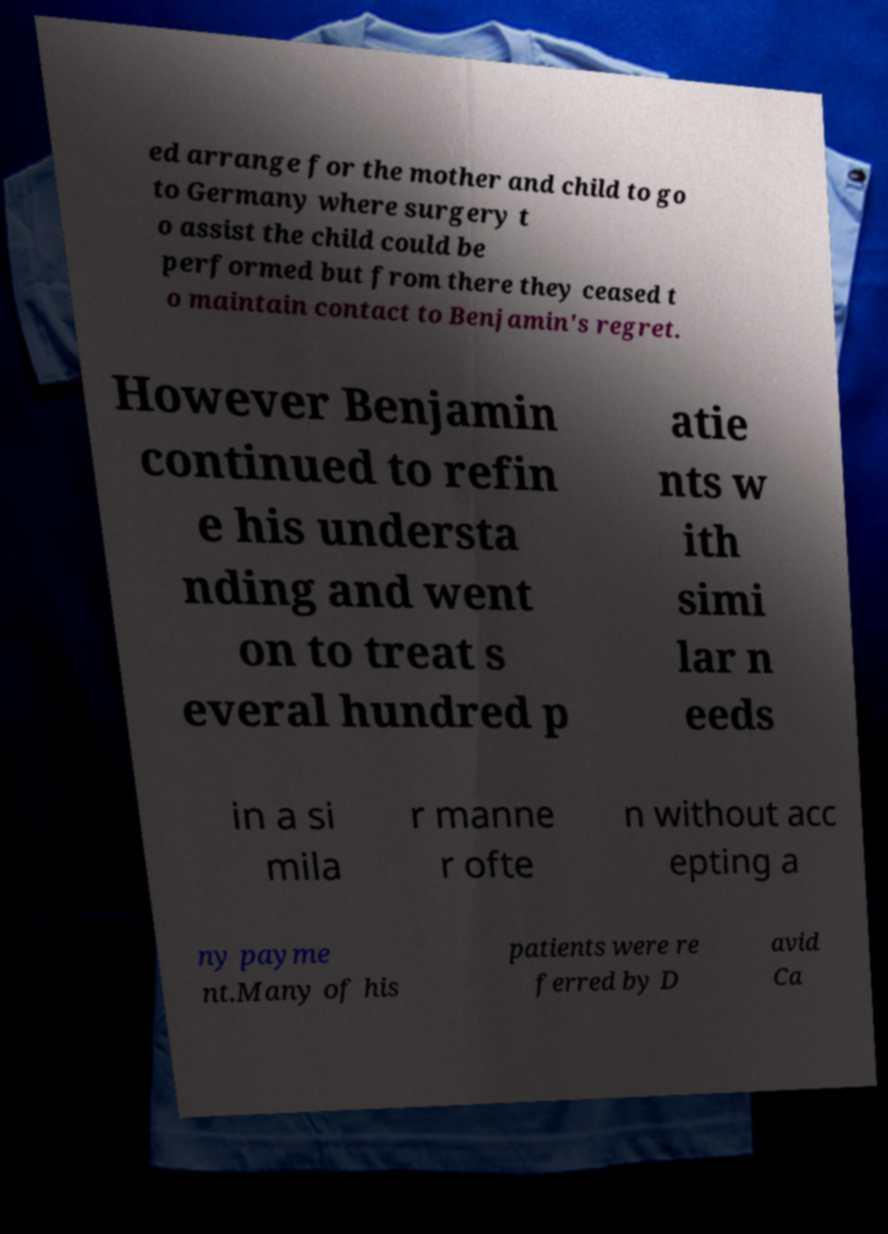Could you assist in decoding the text presented in this image and type it out clearly? ed arrange for the mother and child to go to Germany where surgery t o assist the child could be performed but from there they ceased t o maintain contact to Benjamin's regret. However Benjamin continued to refin e his understa nding and went on to treat s everal hundred p atie nts w ith simi lar n eeds in a si mila r manne r ofte n without acc epting a ny payme nt.Many of his patients were re ferred by D avid Ca 